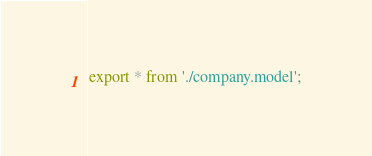Convert code to text. <code><loc_0><loc_0><loc_500><loc_500><_TypeScript_>export * from './company.model';
</code> 